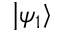<formula> <loc_0><loc_0><loc_500><loc_500>\left | \psi _ { 1 } \right \rangle</formula> 